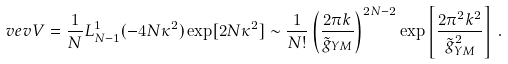Convert formula to latex. <formula><loc_0><loc_0><loc_500><loc_500>\ v e v { V } = \frac { 1 } { N } L _ { N - 1 } ^ { 1 } ( - 4 N \kappa ^ { 2 } ) \exp [ 2 N \kappa ^ { 2 } ] \sim \frac { 1 } { N ! } \left ( \frac { 2 \pi k } { \tilde { g } _ { Y M } } \right ) ^ { 2 N - 2 } \exp \left [ \frac { 2 \pi ^ { 2 } k ^ { 2 } } { \tilde { g } _ { Y M } ^ { 2 } } \right ] \, .</formula> 